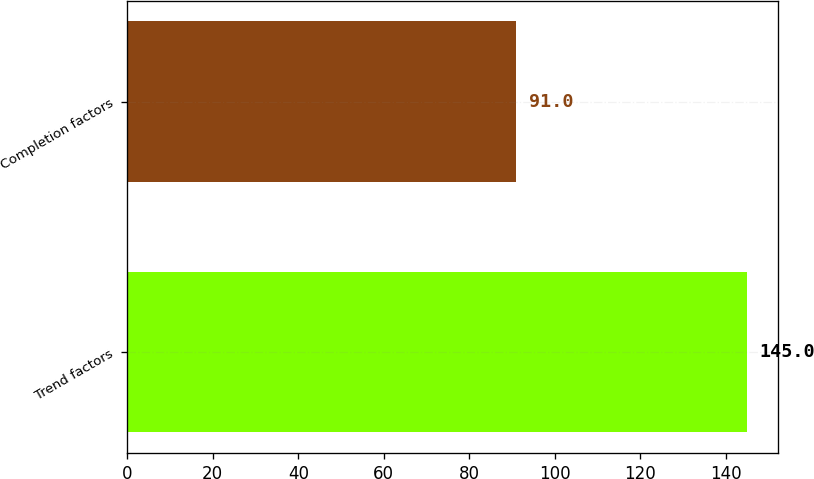Convert chart to OTSL. <chart><loc_0><loc_0><loc_500><loc_500><bar_chart><fcel>Trend factors<fcel>Completion factors<nl><fcel>145<fcel>91<nl></chart> 